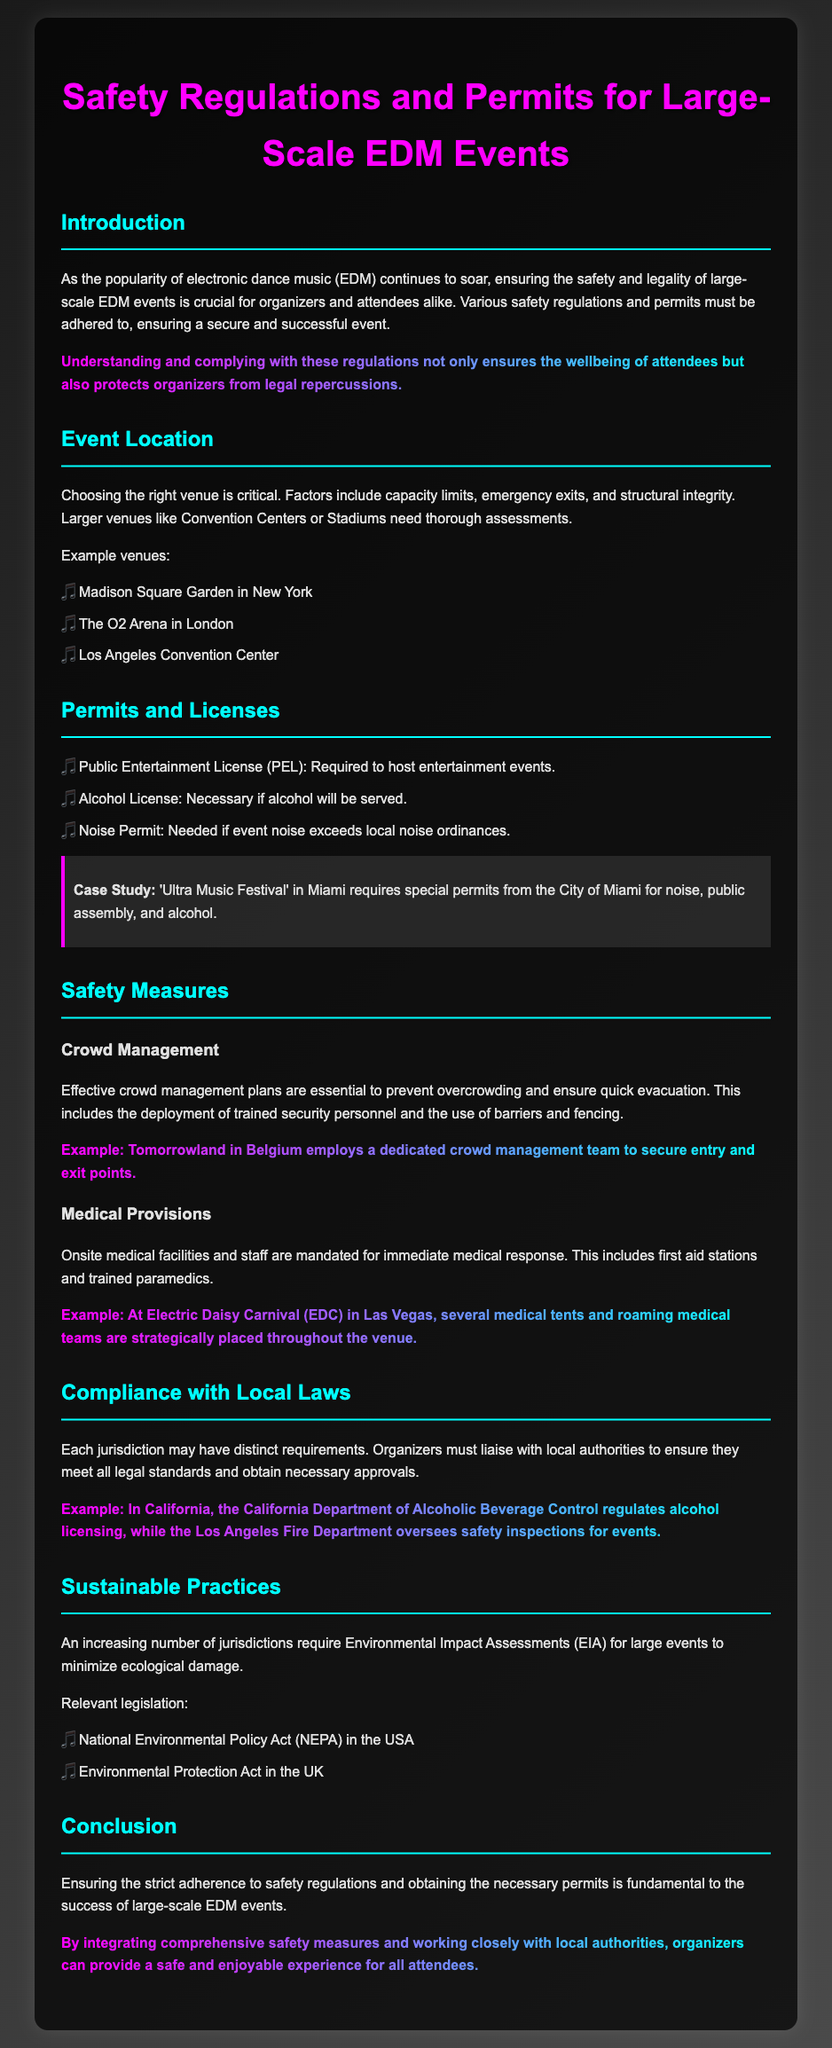What is the purpose of safety regulations for EDM events? The document states that safety regulations ensure the wellbeing of attendees and protect organizers from legal repercussions.
Answer: Wellbeing of attendees Which venue is mentioned as an example in New York? The document lists Madison Square Garden as an example venue in New York.
Answer: Madison Square Garden What type of license is required for serving alcohol? The document indicates that an Alcohol License is necessary if alcohol will be served.
Answer: Alcohol License What example is given for effective crowd management? Tomorrowland in Belgium is provided as an example of an event employing a dedicated crowd management team.
Answer: Tomorrowland What department regulates alcohol licensing in California? The document mentions the California Department of Alcoholic Beverage Control as the regulating body for alcohol licensing in California.
Answer: California Department of Alcoholic Beverage Control 